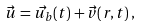<formula> <loc_0><loc_0><loc_500><loc_500>\vec { u } = \vec { u _ { b } } ( t ) + \vec { v } ( r , t ) \, ,</formula> 